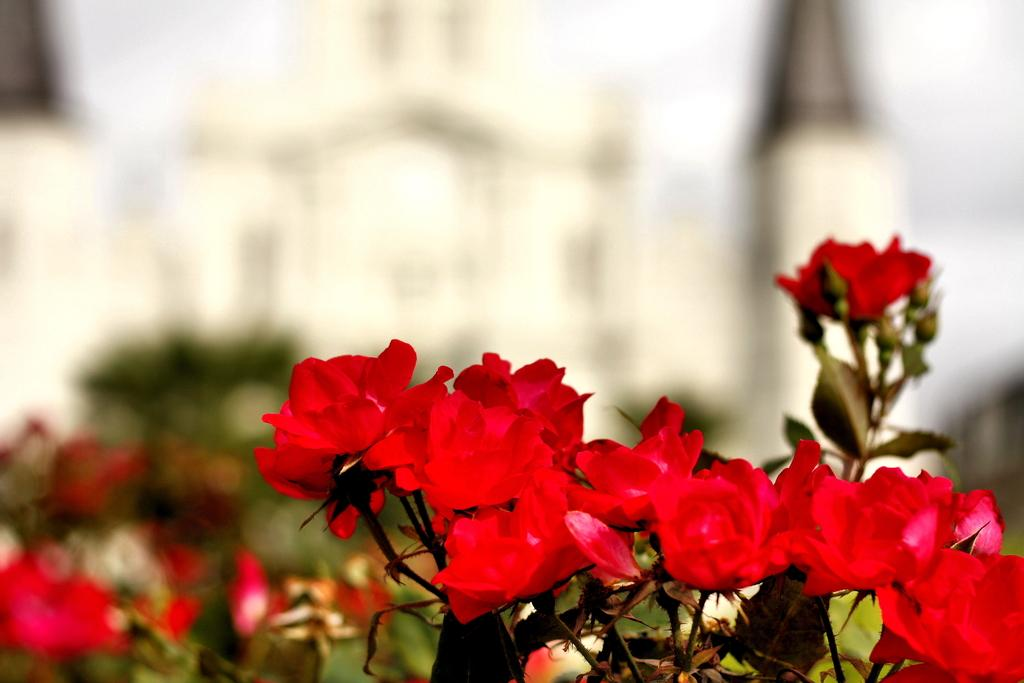What type of living organisms can be seen in the image? Plants can be seen in the image. What color are the flowers on the plants? The flowers on the plants are red. Can you describe the background of the image? The background of the image is blurred. What is the tendency of the clock in the image? There is no clock present in the image, so it's not possible to determine its tendency. 